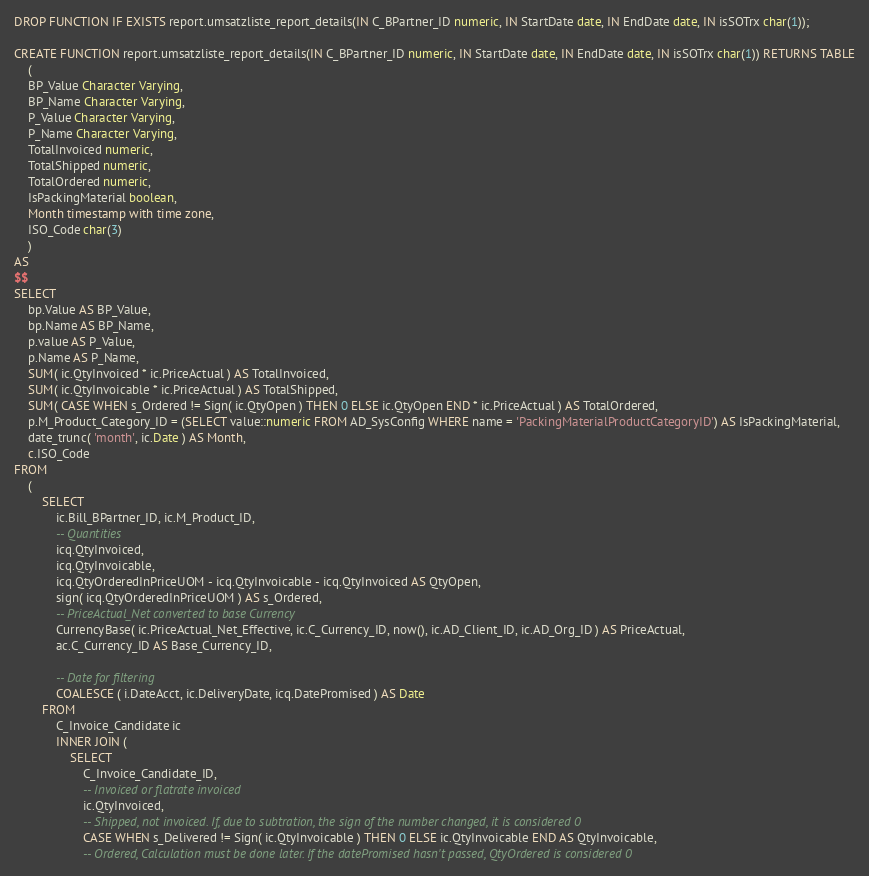Convert code to text. <code><loc_0><loc_0><loc_500><loc_500><_SQL_>DROP FUNCTION IF EXISTS report.umsatzliste_report_details(IN C_BPartner_ID numeric, IN StartDate date, IN EndDate date, IN isSOTrx char(1));

CREATE FUNCTION report.umsatzliste_report_details(IN C_BPartner_ID numeric, IN StartDate date, IN EndDate date, IN isSOTrx char(1)) RETURNS TABLE
	(
	BP_Value Character Varying,
	BP_Name Character Varying, 
	P_Value Character Varying,
	P_Name Character Varying,
	TotalInvoiced numeric,
	TotalShipped numeric,
	TotalOrdered numeric,
	IsPackingMaterial boolean,
	Month timestamp with time zone,
	ISO_Code char(3)
	)
AS 
$$
SELECT
	bp.Value AS BP_Value,
	bp.Name AS BP_Name,
	p.value AS P_Value,
	p.Name AS P_Name,
	SUM( ic.QtyInvoiced * ic.PriceActual ) AS TotalInvoiced,
	SUM( ic.QtyInvoicable * ic.PriceActual ) AS TotalShipped,
	SUM( CASE WHEN s_Ordered != Sign( ic.QtyOpen ) THEN 0 ELSE ic.QtyOpen END * ic.PriceActual ) AS TotalOrdered,
	p.M_Product_Category_ID = (SELECT value::numeric FROM AD_SysConfig WHERE name = 'PackingMaterialProductCategoryID') AS IsPackingMaterial,
	date_trunc( 'month', ic.Date ) AS Month,
	c.ISO_Code
FROM
	(
		SELECT
			ic.Bill_BPartner_ID, ic.M_Product_ID,
			-- Quantities
			icq.QtyInvoiced,
			icq.QtyInvoicable,
			icq.QtyOrderedInPriceUOM - icq.QtyInvoicable - icq.QtyInvoiced AS QtyOpen,
			sign( icq.QtyOrderedInPriceUOM ) AS s_Ordered,
			-- PriceActual_Net converted to base Currency
			CurrencyBase( ic.PriceActual_Net_Effective, ic.C_Currency_ID, now(), ic.AD_Client_ID, ic.AD_Org_ID ) AS PriceActual,
			ac.C_Currency_ID AS Base_Currency_ID,

			-- Date for filtering
			COALESCE ( i.DateAcct, ic.DeliveryDate, icq.DatePromised ) AS Date
		FROM
			C_Invoice_Candidate ic
			INNER JOIN (
				SELECT
					C_Invoice_Candidate_ID,
					-- Invoiced or flatrate invoiced
					ic.QtyInvoiced,
					-- Shipped, not invoiced. If, due to subtration, the sign of the number changed, it is considered 0
					CASE WHEN s_Delivered != Sign( ic.QtyInvoicable ) THEN 0 ELSE ic.QtyInvoicable END AS QtyInvoicable,
					-- Ordered, Calculation must be done later. If the datePromised hasn't passed, QtyOrdered is considered 0</code> 